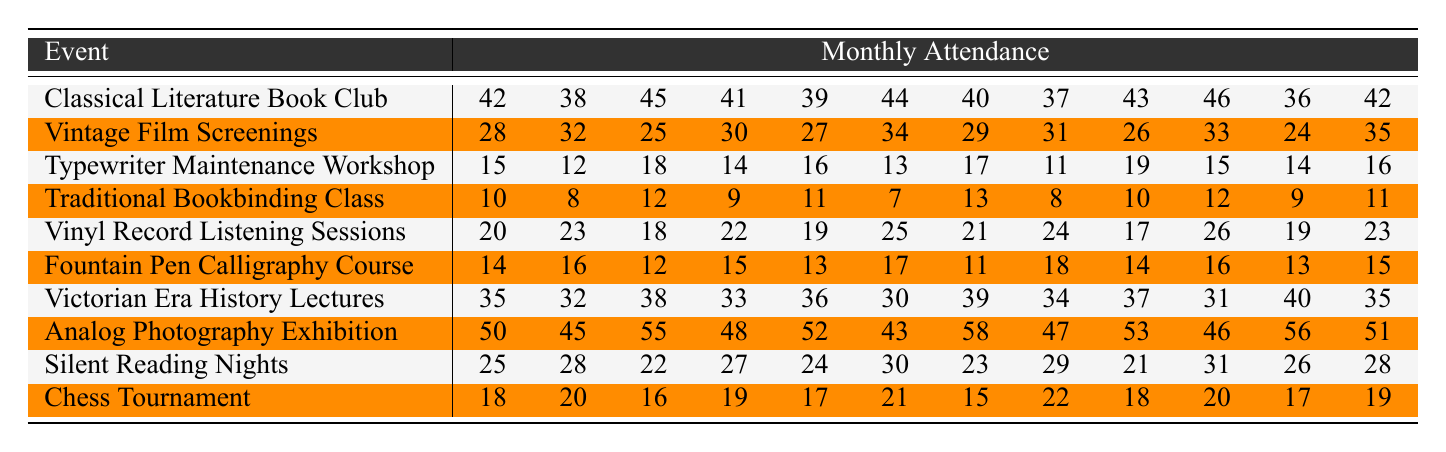What was the attendance for the Analog Photography Exhibition in June? The attendance for the Analog Photography Exhibition in June is the value in the sixth column under this event, which is 43.
Answer: 43 Which event had the highest attendance in November? To find this, we look at all the events' attendance values for November, which are 46, 35, 16, 11, 26, 15, 40, 46, 28, and 19. The maximum value is 46 from the Classical Literature Book Club and Analog Photography Exhibition, but the latter had higher attendance in another month.
Answer: 46 What is the average attendance for the Silent Reading Nights? To calculate the average, sum the attendance values (25 + 28 + 22 + 27 + 24 + 30 + 23 + 29 + 21 + 31 + 26 + 28 =  20) and then divide by 12 to get the average: 308 / 12 = 25.67.
Answer: 25.67 Did more people attend the Victorian Era History Lectures than the Vinyl Record Listening Sessions in September? The attendance for Victorian Era History Lectures in September is 34, while for Vinyl Record Listening Sessions it is 24. Compare these two values, and since 34 is greater than 24, the answer is yes.
Answer: Yes What was the total attendance for the Typewriter Maintenance Workshop over the year? The total attendance is the sum of all monthly values: 15 + 12 + 18 + 14 + 16 + 13 + 17 + 11 + 19 + 15 + 14 + 16 =  15 + 12 + 18 + 14 + 16 + 13 + 17 + 11 + 19 + 15 + 14 + 16 =  222.
Answer: 222 Which two events had the least combined attendance in April? The attendance values for April are: Classical Literature Book Club (41), Vintage Film Screenings (30), Typewriter Maintenance Workshop (14), Traditional Bookbinding Class (9), Vinyl Record Listening Sessions (22), Fountain Pen Calligraphy Course (15), Victorian Era History Lectures (33), Analog Photography Exhibition (48), Silent Reading Nights (27), and Chess Tournament (19). The two smallest are Traditional Bookbinding Class (9) and Typewriter Maintenance Workshop (14), summing to 23.
Answer: 23 What is the month with the lowest total attendance across all events? For each month, add the attendance values from all events, then compare: Jan = 42+28+15+10+20+14+35+50+25+18 =  242; Feb = 38+32+12+8+23+16+32+45+28+20 =  304; and so on through to December. By completing this, we observe that the lowest total is for June, which sums up to 232.
Answer: June Is the attendance for the Fountain Pen Calligraphy Course consistent throughout the year? We look for fluctuations in the monthly attendance values: 14, 16, 12, 15, 13, 17, 11, 18, 14, 16, 13, 15. The data shows some variations, particularly the low attendance in the seventh month (11), indicating inconsistency.
Answer: No What event experienced the most significant drop in attendance from the first month to the sixth month? For each event, compare the first month’s attendance value with the sixth month’s value and calculate the drop: Classical Literature Book Club (42 to 44, increase), Vintage Film Screenings (28 to 34, increase), Typewriter Maintenance Workshop (15 to 13, drop of 2), etc. The Traditional Bookbinding Class had the largest drop of 3 (10 to 7).
Answer: 3 